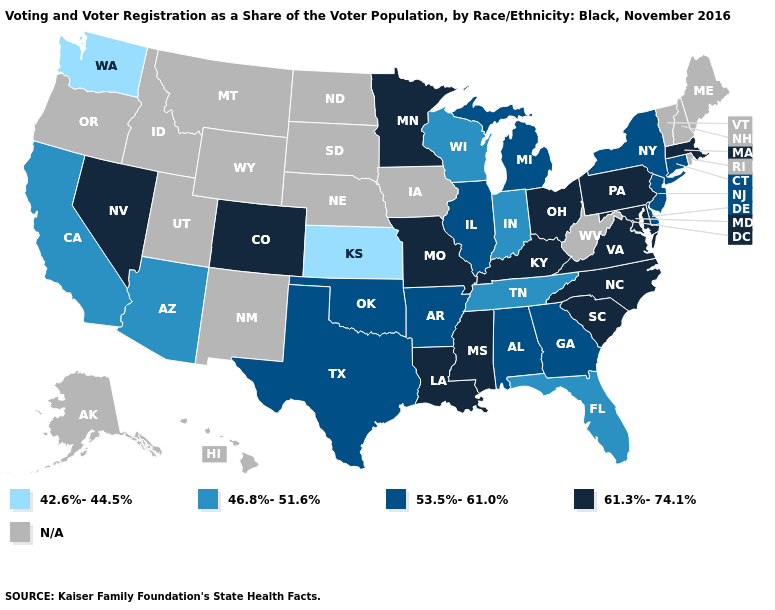Among the states that border New Mexico , which have the lowest value?
Write a very short answer. Arizona. Among the states that border New Jersey , does Pennsylvania have the highest value?
Quick response, please. Yes. Does Colorado have the highest value in the West?
Short answer required. Yes. Which states hav the highest value in the MidWest?
Short answer required. Minnesota, Missouri, Ohio. Among the states that border Georgia , which have the lowest value?
Give a very brief answer. Florida, Tennessee. What is the value of Virginia?
Give a very brief answer. 61.3%-74.1%. Does the first symbol in the legend represent the smallest category?
Short answer required. Yes. What is the value of North Dakota?
Short answer required. N/A. Name the states that have a value in the range 46.8%-51.6%?
Write a very short answer. Arizona, California, Florida, Indiana, Tennessee, Wisconsin. Name the states that have a value in the range 61.3%-74.1%?
Be succinct. Colorado, Kentucky, Louisiana, Maryland, Massachusetts, Minnesota, Mississippi, Missouri, Nevada, North Carolina, Ohio, Pennsylvania, South Carolina, Virginia. What is the value of North Dakota?
Keep it brief. N/A. Name the states that have a value in the range 61.3%-74.1%?
Write a very short answer. Colorado, Kentucky, Louisiana, Maryland, Massachusetts, Minnesota, Mississippi, Missouri, Nevada, North Carolina, Ohio, Pennsylvania, South Carolina, Virginia. What is the value of Georgia?
Write a very short answer. 53.5%-61.0%. Does the map have missing data?
Keep it brief. Yes. 